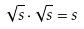<formula> <loc_0><loc_0><loc_500><loc_500>\sqrt { s } \cdot \sqrt { s } = s</formula> 